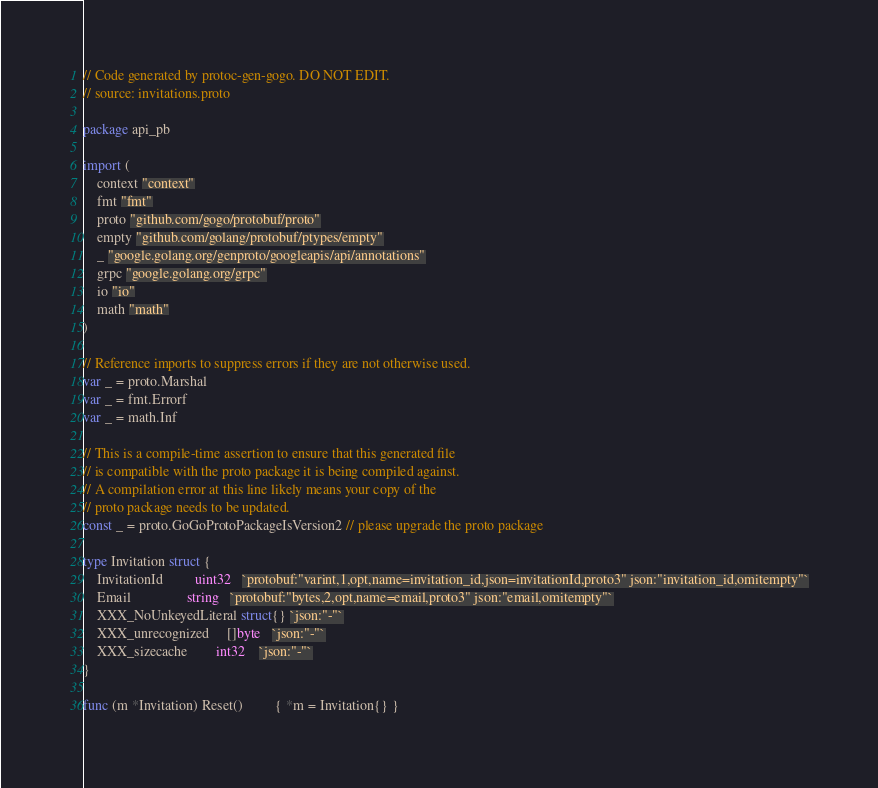Convert code to text. <code><loc_0><loc_0><loc_500><loc_500><_Go_>// Code generated by protoc-gen-gogo. DO NOT EDIT.
// source: invitations.proto

package api_pb

import (
	context "context"
	fmt "fmt"
	proto "github.com/gogo/protobuf/proto"
	empty "github.com/golang/protobuf/ptypes/empty"
	_ "google.golang.org/genproto/googleapis/api/annotations"
	grpc "google.golang.org/grpc"
	io "io"
	math "math"
)

// Reference imports to suppress errors if they are not otherwise used.
var _ = proto.Marshal
var _ = fmt.Errorf
var _ = math.Inf

// This is a compile-time assertion to ensure that this generated file
// is compatible with the proto package it is being compiled against.
// A compilation error at this line likely means your copy of the
// proto package needs to be updated.
const _ = proto.GoGoProtoPackageIsVersion2 // please upgrade the proto package

type Invitation struct {
	InvitationId         uint32   `protobuf:"varint,1,opt,name=invitation_id,json=invitationId,proto3" json:"invitation_id,omitempty"`
	Email                string   `protobuf:"bytes,2,opt,name=email,proto3" json:"email,omitempty"`
	XXX_NoUnkeyedLiteral struct{} `json:"-"`
	XXX_unrecognized     []byte   `json:"-"`
	XXX_sizecache        int32    `json:"-"`
}

func (m *Invitation) Reset()         { *m = Invitation{} }</code> 